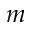<formula> <loc_0><loc_0><loc_500><loc_500>m</formula> 